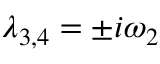<formula> <loc_0><loc_0><loc_500><loc_500>\lambda _ { 3 , 4 } = \pm i \omega _ { 2 }</formula> 